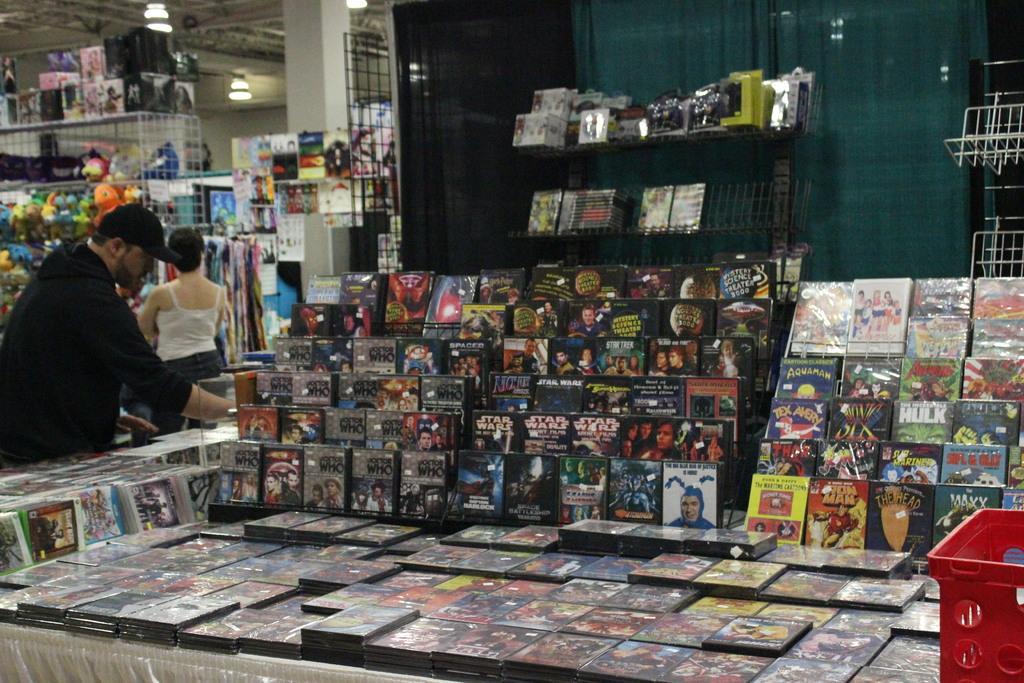Could you give a brief overview of what you see in this image? In this image we can see there are so many book shelves on the table, behind that table there is a shelf with some books in it, beside the bookshelf there is a man standing and checking for books, also there is a lady standing beside the shelf where we can see there are so many toys in it, also there are some things behind the shelves. 